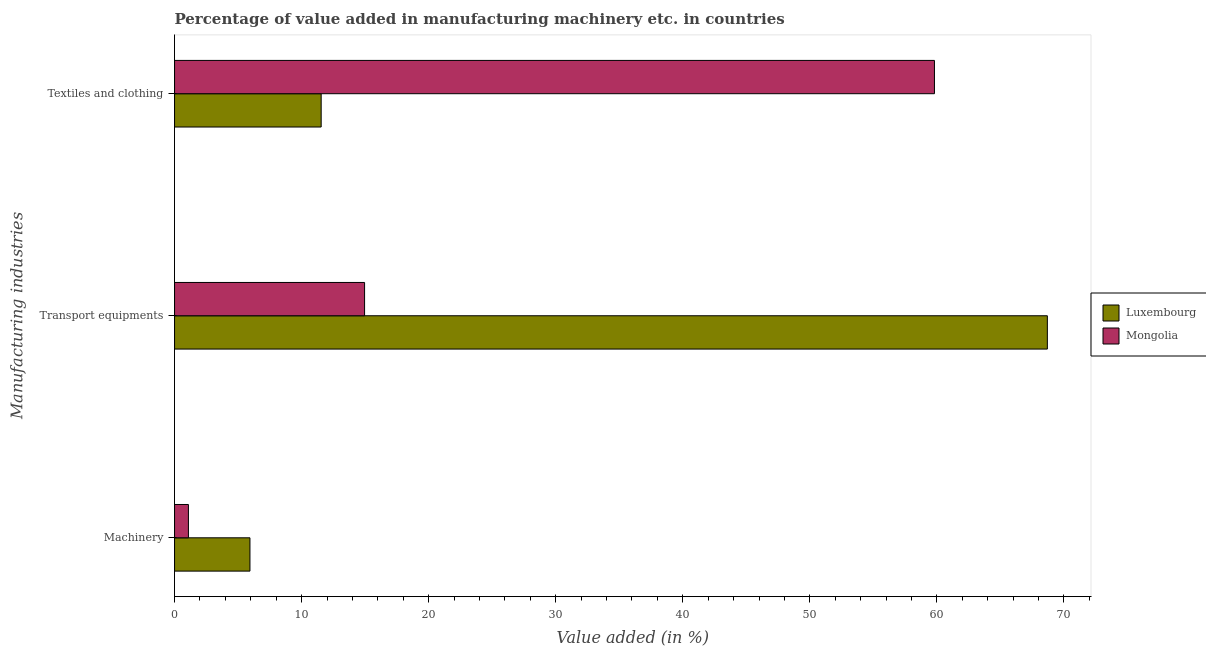Are the number of bars per tick equal to the number of legend labels?
Provide a succinct answer. Yes. Are the number of bars on each tick of the Y-axis equal?
Offer a terse response. Yes. How many bars are there on the 2nd tick from the top?
Your answer should be very brief. 2. What is the label of the 3rd group of bars from the top?
Your answer should be very brief. Machinery. What is the value added in manufacturing textile and clothing in Mongolia?
Your answer should be compact. 59.81. Across all countries, what is the maximum value added in manufacturing machinery?
Your answer should be very brief. 5.94. Across all countries, what is the minimum value added in manufacturing transport equipments?
Give a very brief answer. 14.96. In which country was the value added in manufacturing transport equipments maximum?
Your answer should be compact. Luxembourg. In which country was the value added in manufacturing textile and clothing minimum?
Offer a very short reply. Luxembourg. What is the total value added in manufacturing machinery in the graph?
Offer a very short reply. 7.03. What is the difference between the value added in manufacturing transport equipments in Luxembourg and that in Mongolia?
Give a very brief answer. 53.74. What is the difference between the value added in manufacturing textile and clothing in Mongolia and the value added in manufacturing transport equipments in Luxembourg?
Provide a short and direct response. -8.89. What is the average value added in manufacturing transport equipments per country?
Your answer should be compact. 41.82. What is the difference between the value added in manufacturing machinery and value added in manufacturing transport equipments in Luxembourg?
Your response must be concise. -62.76. In how many countries, is the value added in manufacturing machinery greater than 68 %?
Your answer should be compact. 0. What is the ratio of the value added in manufacturing textile and clothing in Luxembourg to that in Mongolia?
Give a very brief answer. 0.19. Is the value added in manufacturing machinery in Mongolia less than that in Luxembourg?
Offer a very short reply. Yes. What is the difference between the highest and the second highest value added in manufacturing textile and clothing?
Offer a very short reply. 48.27. What is the difference between the highest and the lowest value added in manufacturing machinery?
Your response must be concise. 4.84. In how many countries, is the value added in manufacturing machinery greater than the average value added in manufacturing machinery taken over all countries?
Make the answer very short. 1. What does the 2nd bar from the top in Transport equipments represents?
Your answer should be compact. Luxembourg. What does the 1st bar from the bottom in Machinery represents?
Offer a very short reply. Luxembourg. Is it the case that in every country, the sum of the value added in manufacturing machinery and value added in manufacturing transport equipments is greater than the value added in manufacturing textile and clothing?
Provide a short and direct response. No. How many bars are there?
Make the answer very short. 6. Does the graph contain any zero values?
Your answer should be compact. No. Does the graph contain grids?
Give a very brief answer. No. How many legend labels are there?
Offer a terse response. 2. What is the title of the graph?
Your answer should be compact. Percentage of value added in manufacturing machinery etc. in countries. What is the label or title of the X-axis?
Your answer should be very brief. Value added (in %). What is the label or title of the Y-axis?
Provide a succinct answer. Manufacturing industries. What is the Value added (in %) in Luxembourg in Machinery?
Make the answer very short. 5.94. What is the Value added (in %) of Mongolia in Machinery?
Make the answer very short. 1.09. What is the Value added (in %) in Luxembourg in Transport equipments?
Provide a succinct answer. 68.69. What is the Value added (in %) in Mongolia in Transport equipments?
Provide a succinct answer. 14.96. What is the Value added (in %) of Luxembourg in Textiles and clothing?
Provide a succinct answer. 11.54. What is the Value added (in %) in Mongolia in Textiles and clothing?
Provide a succinct answer. 59.81. Across all Manufacturing industries, what is the maximum Value added (in %) in Luxembourg?
Offer a very short reply. 68.69. Across all Manufacturing industries, what is the maximum Value added (in %) in Mongolia?
Your response must be concise. 59.81. Across all Manufacturing industries, what is the minimum Value added (in %) in Luxembourg?
Your answer should be compact. 5.94. Across all Manufacturing industries, what is the minimum Value added (in %) in Mongolia?
Provide a succinct answer. 1.09. What is the total Value added (in %) of Luxembourg in the graph?
Your answer should be very brief. 86.17. What is the total Value added (in %) of Mongolia in the graph?
Your answer should be compact. 75.85. What is the difference between the Value added (in %) in Luxembourg in Machinery and that in Transport equipments?
Offer a very short reply. -62.76. What is the difference between the Value added (in %) in Mongolia in Machinery and that in Transport equipments?
Make the answer very short. -13.86. What is the difference between the Value added (in %) in Luxembourg in Machinery and that in Textiles and clothing?
Ensure brevity in your answer.  -5.6. What is the difference between the Value added (in %) in Mongolia in Machinery and that in Textiles and clothing?
Make the answer very short. -58.72. What is the difference between the Value added (in %) of Luxembourg in Transport equipments and that in Textiles and clothing?
Give a very brief answer. 57.15. What is the difference between the Value added (in %) in Mongolia in Transport equipments and that in Textiles and clothing?
Ensure brevity in your answer.  -44.85. What is the difference between the Value added (in %) in Luxembourg in Machinery and the Value added (in %) in Mongolia in Transport equipments?
Give a very brief answer. -9.02. What is the difference between the Value added (in %) in Luxembourg in Machinery and the Value added (in %) in Mongolia in Textiles and clothing?
Offer a very short reply. -53.87. What is the difference between the Value added (in %) in Luxembourg in Transport equipments and the Value added (in %) in Mongolia in Textiles and clothing?
Provide a short and direct response. 8.89. What is the average Value added (in %) of Luxembourg per Manufacturing industries?
Provide a short and direct response. 28.72. What is the average Value added (in %) of Mongolia per Manufacturing industries?
Your response must be concise. 25.28. What is the difference between the Value added (in %) in Luxembourg and Value added (in %) in Mongolia in Machinery?
Your response must be concise. 4.84. What is the difference between the Value added (in %) in Luxembourg and Value added (in %) in Mongolia in Transport equipments?
Provide a short and direct response. 53.74. What is the difference between the Value added (in %) of Luxembourg and Value added (in %) of Mongolia in Textiles and clothing?
Your answer should be very brief. -48.27. What is the ratio of the Value added (in %) of Luxembourg in Machinery to that in Transport equipments?
Give a very brief answer. 0.09. What is the ratio of the Value added (in %) of Mongolia in Machinery to that in Transport equipments?
Your answer should be very brief. 0.07. What is the ratio of the Value added (in %) in Luxembourg in Machinery to that in Textiles and clothing?
Your answer should be compact. 0.51. What is the ratio of the Value added (in %) in Mongolia in Machinery to that in Textiles and clothing?
Offer a very short reply. 0.02. What is the ratio of the Value added (in %) of Luxembourg in Transport equipments to that in Textiles and clothing?
Keep it short and to the point. 5.95. What is the ratio of the Value added (in %) in Mongolia in Transport equipments to that in Textiles and clothing?
Offer a very short reply. 0.25. What is the difference between the highest and the second highest Value added (in %) of Luxembourg?
Ensure brevity in your answer.  57.15. What is the difference between the highest and the second highest Value added (in %) in Mongolia?
Your answer should be compact. 44.85. What is the difference between the highest and the lowest Value added (in %) in Luxembourg?
Ensure brevity in your answer.  62.76. What is the difference between the highest and the lowest Value added (in %) of Mongolia?
Your answer should be very brief. 58.72. 